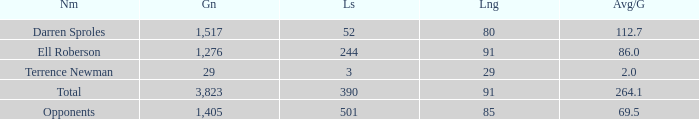When the player gained below 1,405 yards and lost over 390 yards, what's the sum of the long yards? None. 